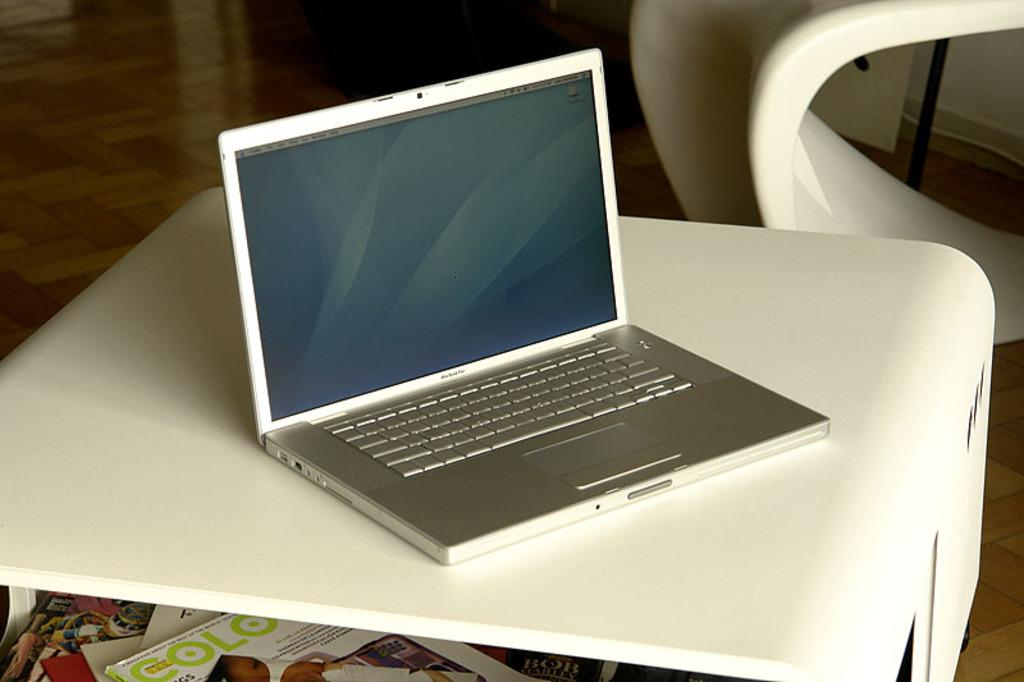What electronic device is present in the image? There is a laptop in the image. What color is the surface on which the laptop is placed? The laptop is on a white color surface. What can be seen in the background of the image? The background of the image includes a brown-colored floor. Are there any other objects visible in the image besides the laptop? Yes, there are books visible in the image. What rule is being enforced by the crying match in the image? There is no crying match or rule present in the image; it features a laptop on a white surface with a brown-colored floor in the background and books nearby. 